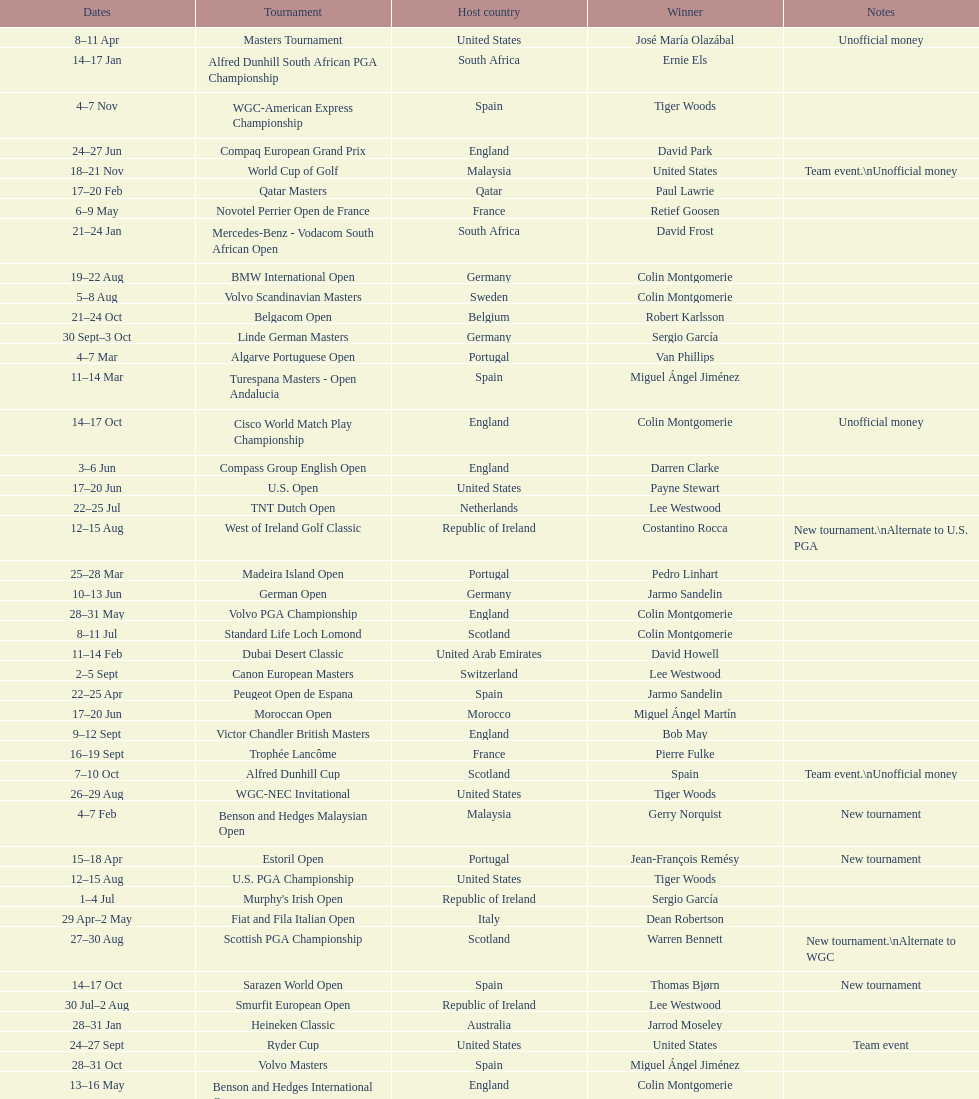How many tournaments began before aug 15th 31. 